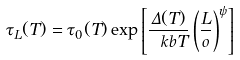<formula> <loc_0><loc_0><loc_500><loc_500>\tau _ { L } ( T ) = \tau _ { 0 } ( T ) \exp \left [ \frac { \Delta ( T ) } { \ k b T } \left ( \frac { L } { \L o } \right ) ^ { \psi } \right ]</formula> 